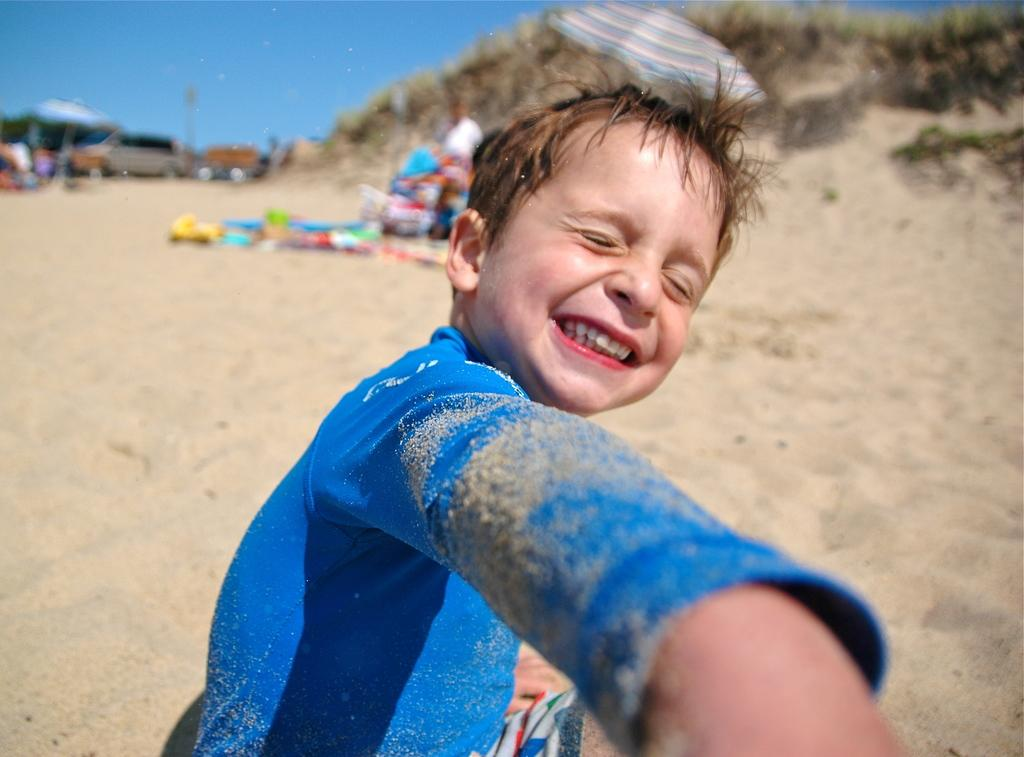What is the boy in the image sitting on? The boy is sitting on sand. What can be seen in the background of the image? In the background of the image, there are persons, an umbrella, grass, vehicles, and the sky. Can you describe the setting of the image? The image appears to be set on a beach, with sand, grass, and an umbrella visible. What might the boy be doing in the image? The boy might be enjoying the beach, as he is sitting on the sand. What type of faucet can be seen in the image? There is no faucet present in the image. How does the boy's anger affect the image? The boy's anger is not mentioned or depicted in the image, so it cannot affect the image. 